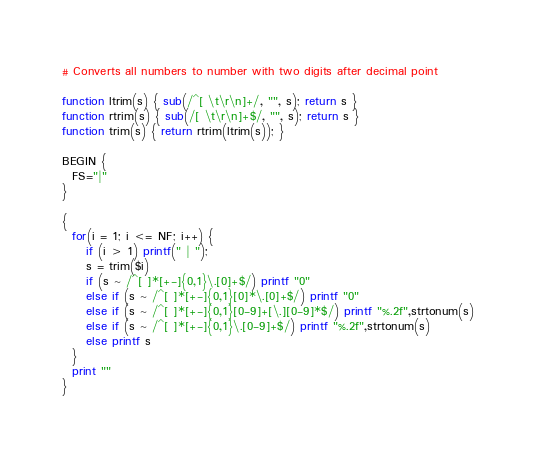<code> <loc_0><loc_0><loc_500><loc_500><_Awk_># Converts all numbers to number with two digits after decimal point

function ltrim(s) { sub(/^[ \t\r\n]+/, "", s); return s }
function rtrim(s) { sub(/[ \t\r\n]+$/, "", s); return s }
function trim(s) { return rtrim(ltrim(s)); }

BEGIN {
  FS="|"
}

{
  for(i = 1; i <= NF; i++) {
     if (i > 1) printf(" | ");
     s = trim($i)
     if (s ~ /^[ ]*[+-]{0,1}\.[0]+$/) printf "0"
     else if (s ~ /^[ ]*[+-]{0,1}[0]*\.[0]+$/) printf "0"
     else if (s ~ /^[ ]*[+-]{0,1}[0-9]+[\.][0-9]*$/) printf "%.2f",strtonum(s)
     else if (s ~ /^[ ]*[+-]{0,1}\.[0-9]+$/) printf "%.2f",strtonum(s)
     else printf s
  }
  print ""
}
</code> 